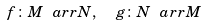<formula> <loc_0><loc_0><loc_500><loc_500>f \colon M \ a r r N , \ \ g \colon N \ a r r M</formula> 